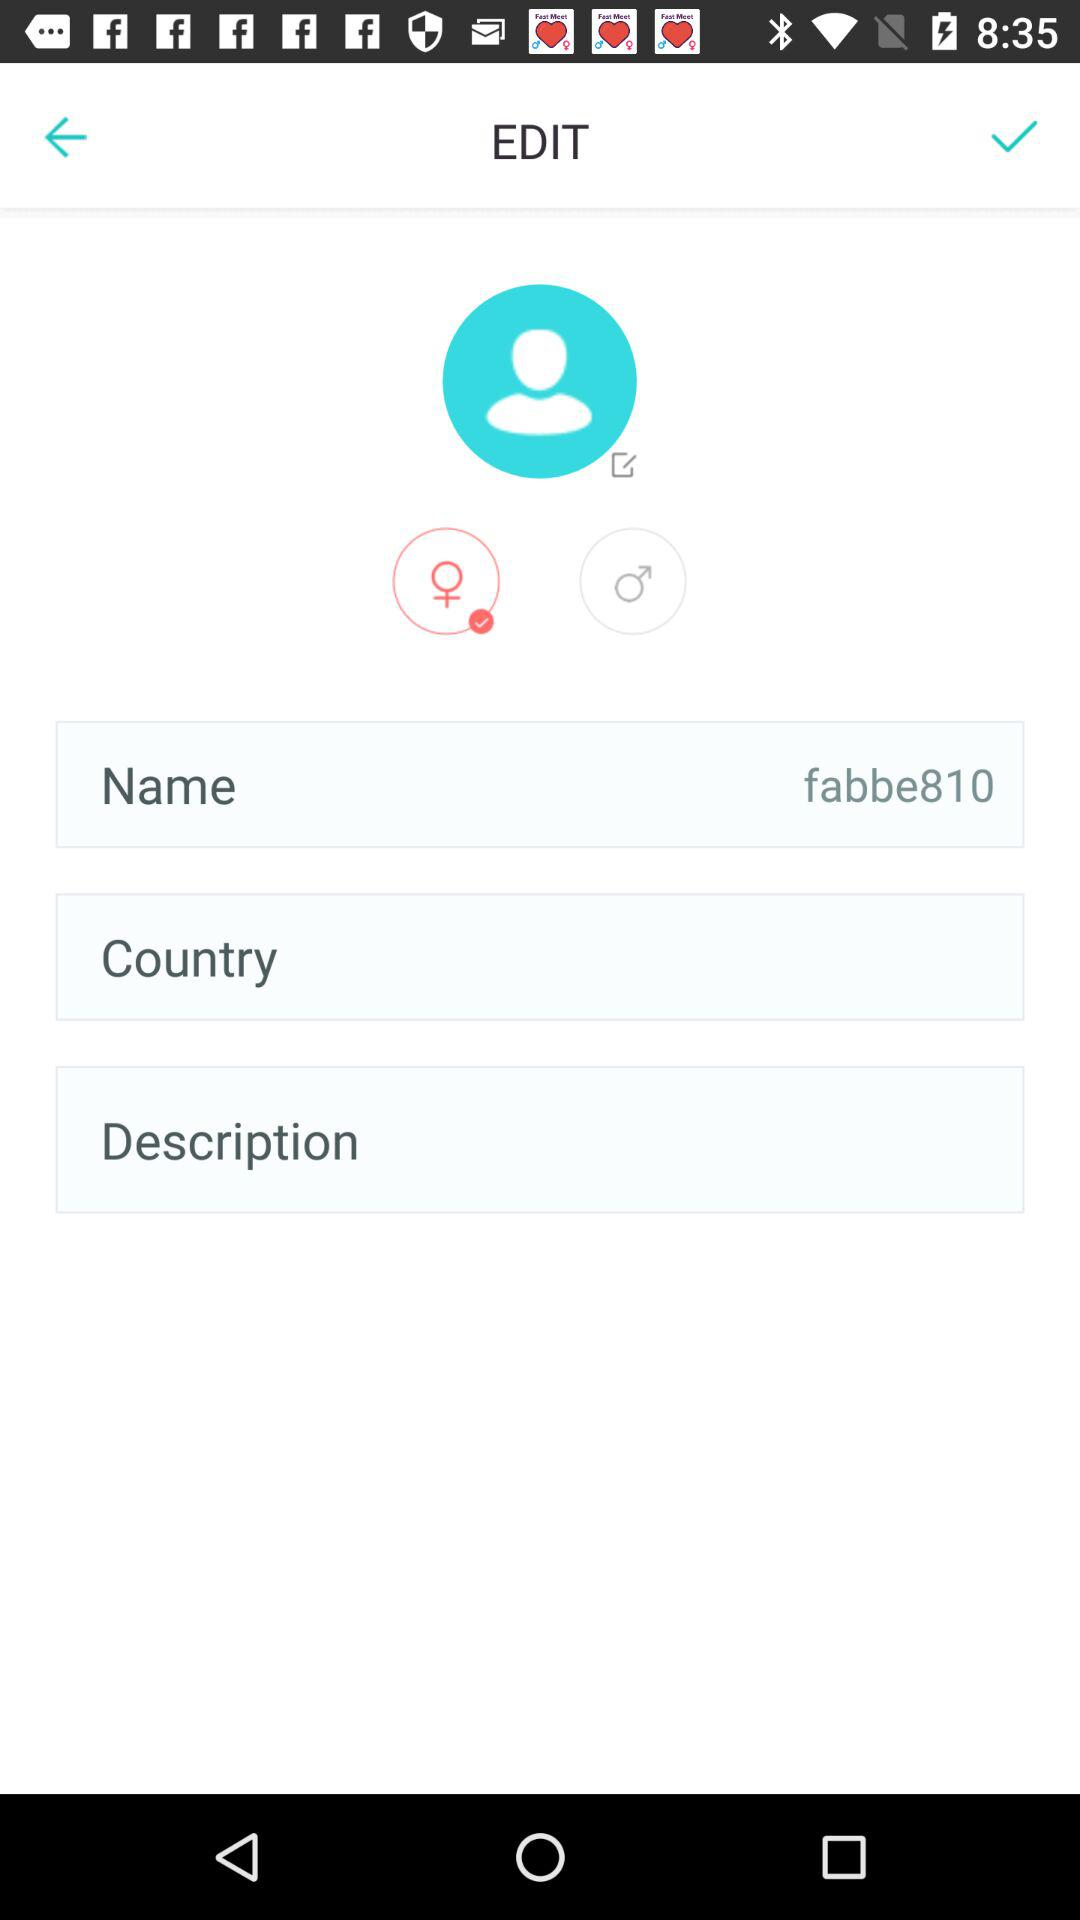What is the username? The username is "fabbe810". 